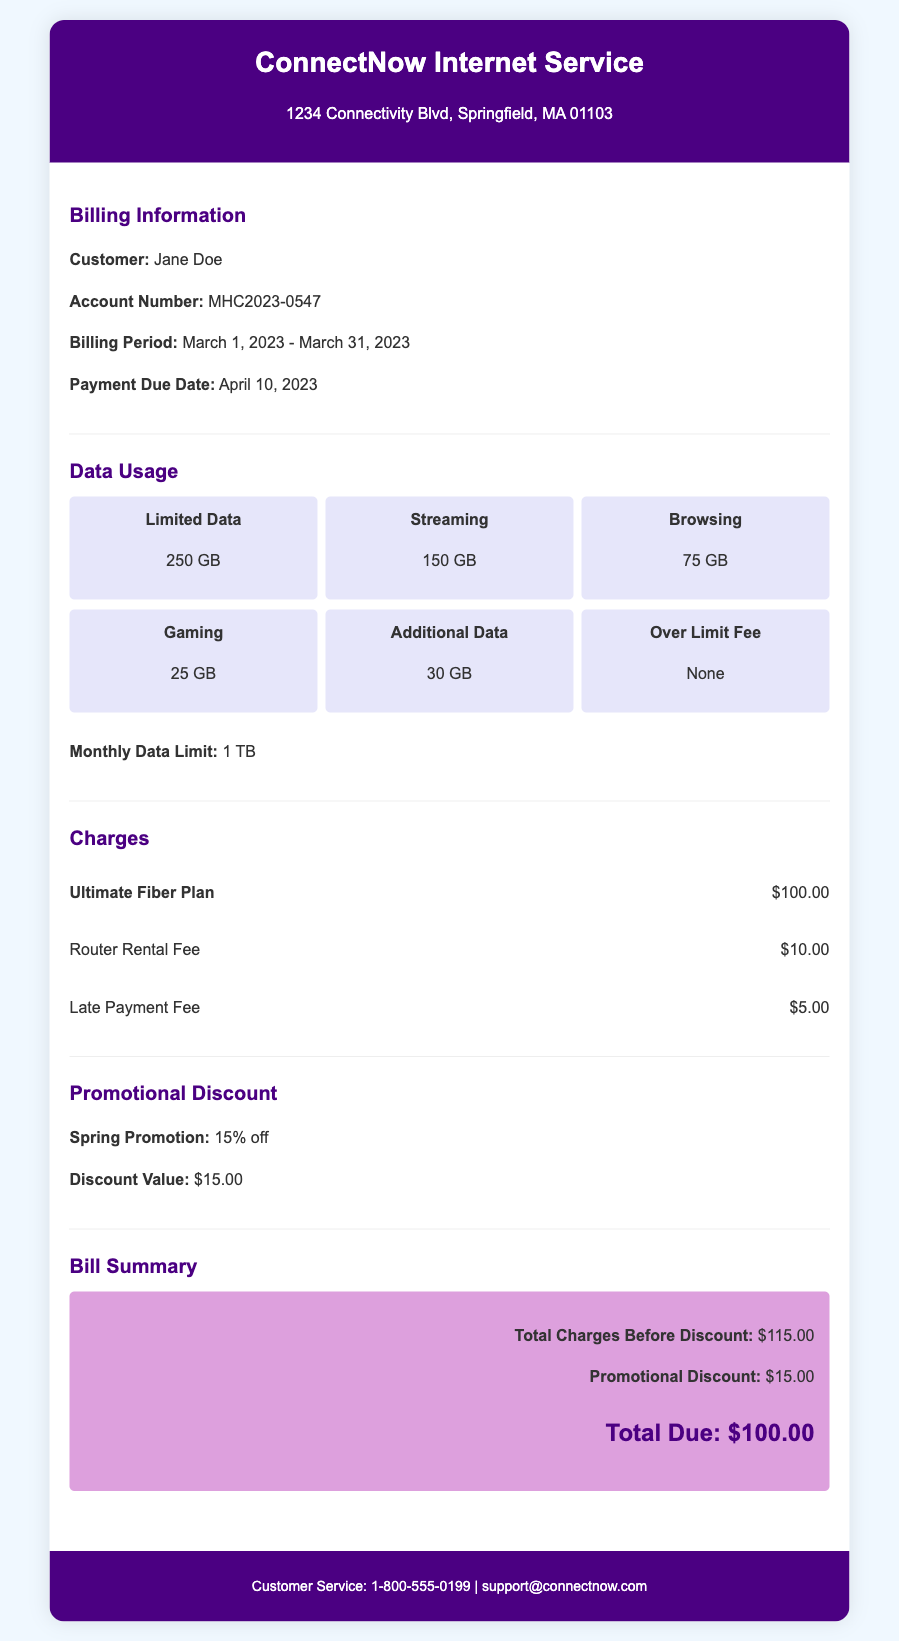What is the customer name? The customer name is mentioned in the Billing Information section.
Answer: Jane Doe What is the account number? The account number is provided in the Billing Information section.
Answer: MHC2023-0547 What is the billing period? The billing period is specified in the Billing Information section.
Answer: March 1, 2023 - March 31, 2023 What is the monthly data limit? The monthly data limit is mentioned in the Data Usage section.
Answer: 1 TB What is the total charge before discount? The total charge before discount is provided in the Bill Summary section.
Answer: $115.00 What is the promotional discount value? The promotional discount value is stated in the Promotional Discount section.
Answer: $15.00 What is the amount due? The total due amount is summarized in the Bill Summary section.
Answer: $100.00 How much is the Router Rental Fee? The Router Rental Fee is listed in the Charges section.
Answer: $10.00 Is there an Over Limit Fee? The Over Limit Fee is indicated in the Data Usage section.
Answer: None 